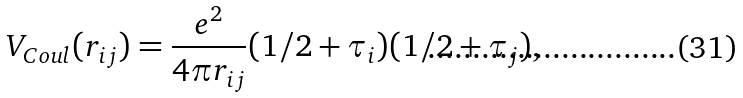Convert formula to latex. <formula><loc_0><loc_0><loc_500><loc_500>V _ { C o u l } ( r _ { i j } ) = \frac { e ^ { 2 } } { 4 \pi r _ { i j } } ( 1 / 2 + \tau _ { i } ) ( 1 / 2 + \tau _ { j } ) ,</formula> 